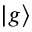<formula> <loc_0><loc_0><loc_500><loc_500>\left | g \right \rangle</formula> 